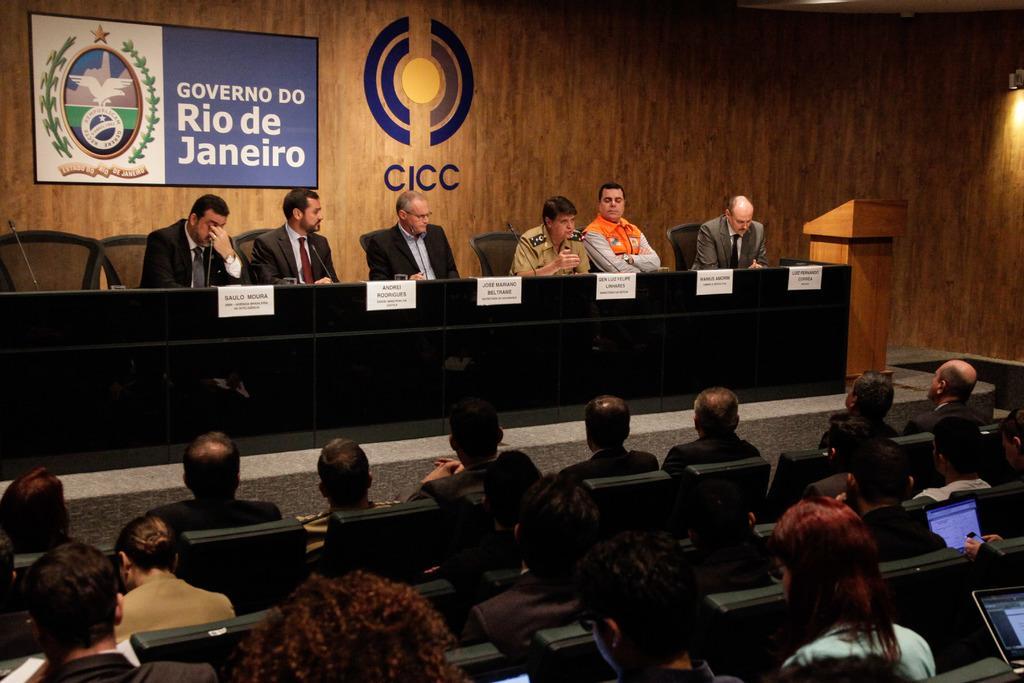Please provide a concise description of this image. In this image there are a few people sitting on the chairs, in front of them there is a table with name plates and mics on it. In the background there is a banner and a logo on the wall. In front of them there are a few people sitting on the chairs and few are placed their laptops on their laps. 